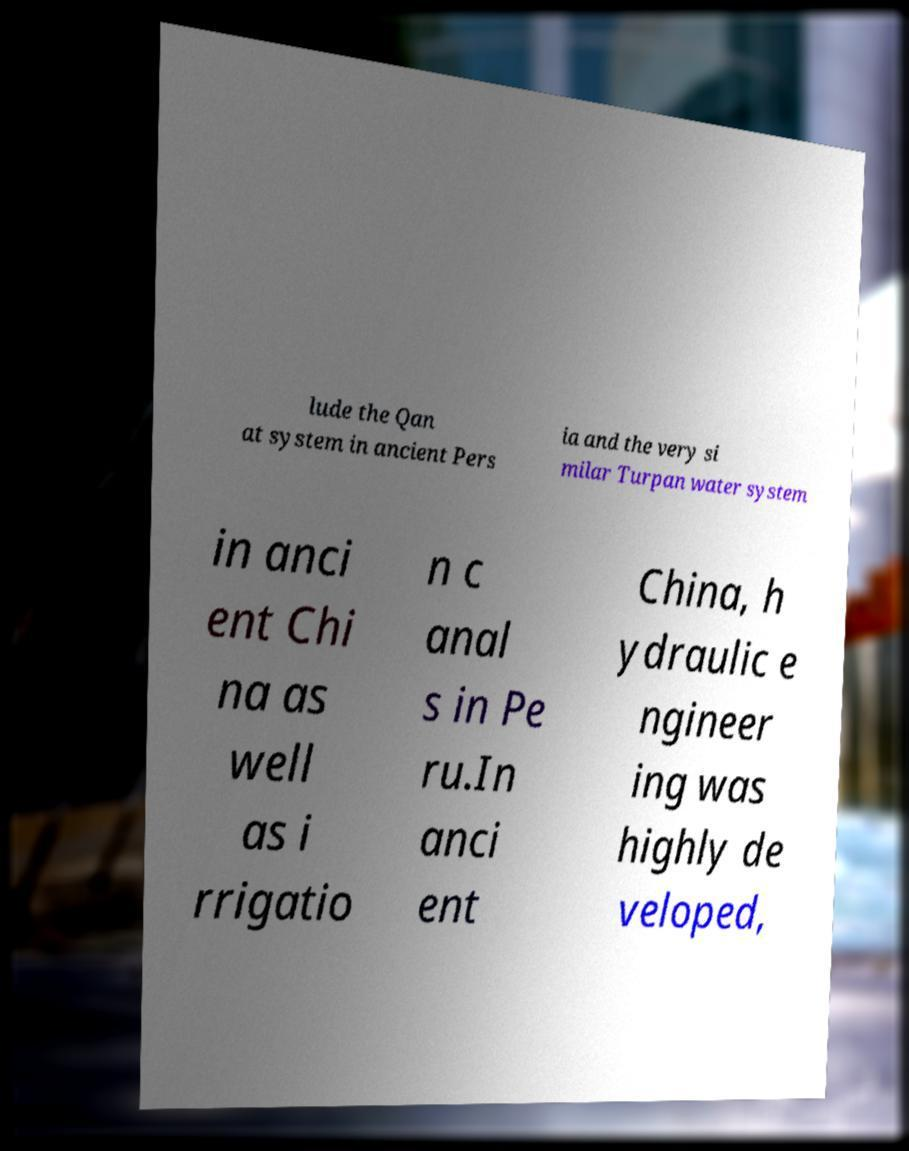What messages or text are displayed in this image? I need them in a readable, typed format. lude the Qan at system in ancient Pers ia and the very si milar Turpan water system in anci ent Chi na as well as i rrigatio n c anal s in Pe ru.In anci ent China, h ydraulic e ngineer ing was highly de veloped, 